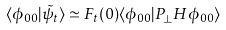<formula> <loc_0><loc_0><loc_500><loc_500>\langle \phi _ { 0 0 } | \tilde { \psi } _ { t } \rangle \simeq F _ { t } ( 0 ) \langle \phi _ { 0 0 } | P _ { \perp } H \phi _ { 0 0 } \rangle</formula> 